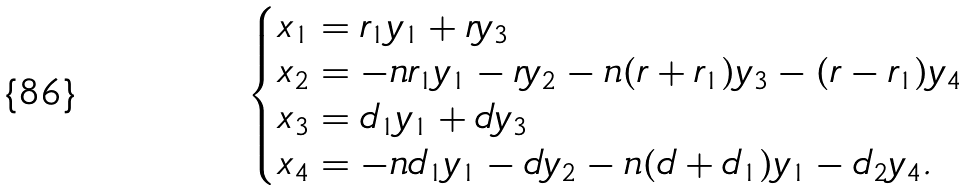<formula> <loc_0><loc_0><loc_500><loc_500>\begin{cases} x _ { 1 } = r _ { 1 } y _ { 1 } + r y _ { 3 } \\ x _ { 2 } = - n r _ { 1 } y _ { 1 } - r y _ { 2 } - n ( r + r _ { 1 } ) y _ { 3 } - ( r - r _ { 1 } ) y _ { 4 } \\ x _ { 3 } = d _ { 1 } y _ { 1 } + d y _ { 3 } \\ x _ { 4 } = - n d _ { 1 } y _ { 1 } - d y _ { 2 } - n ( d + d _ { 1 } ) y _ { 1 } - d _ { 2 } y _ { 4 } . \end{cases}</formula> 